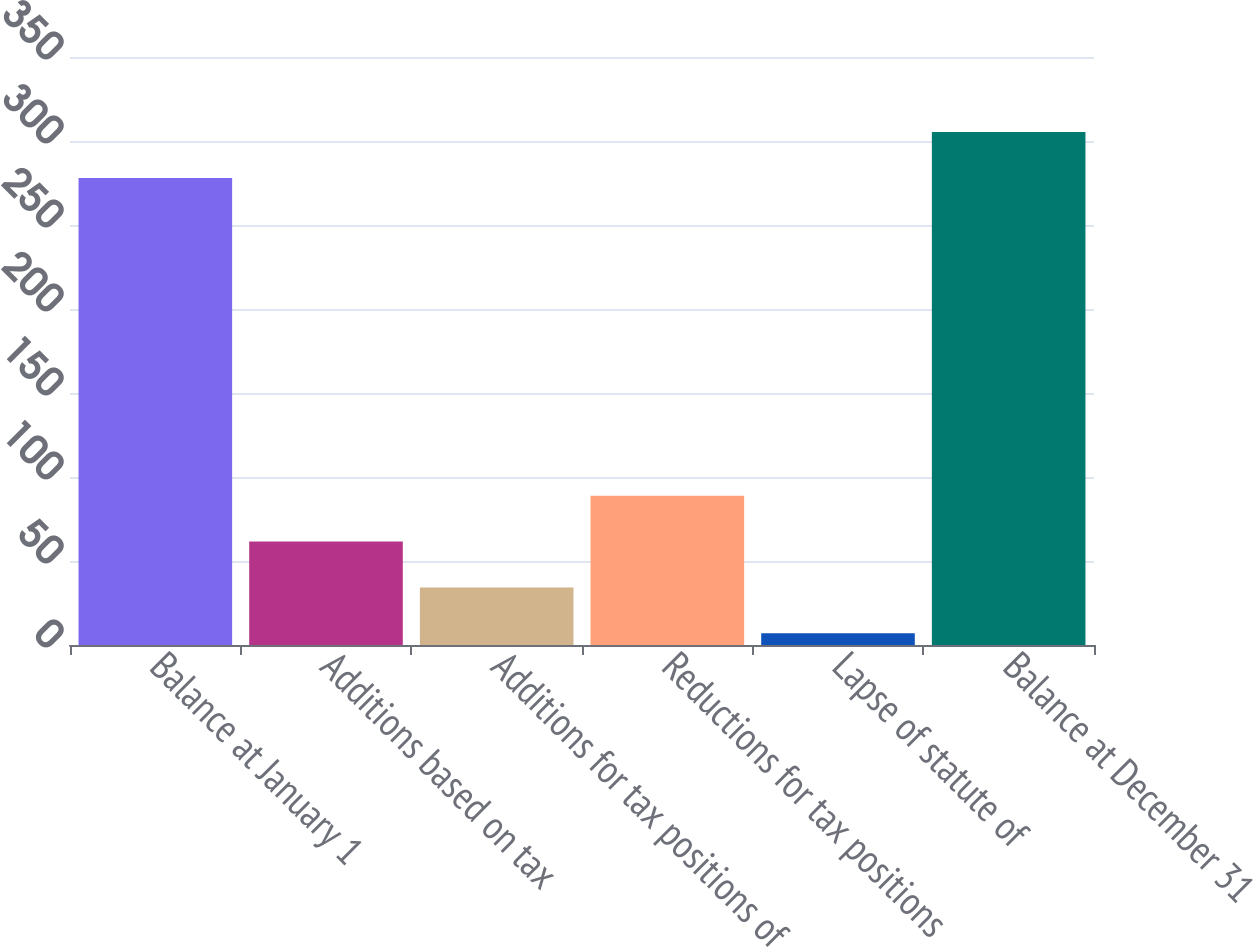Convert chart. <chart><loc_0><loc_0><loc_500><loc_500><bar_chart><fcel>Balance at January 1<fcel>Additions based on tax<fcel>Additions for tax positions of<fcel>Reductions for tax positions<fcel>Lapse of statute of<fcel>Balance at December 31<nl><fcel>278<fcel>61.6<fcel>34.3<fcel>88.9<fcel>7<fcel>305.3<nl></chart> 